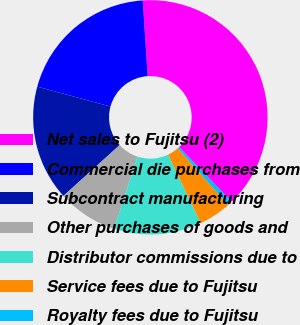Convert chart to OTSL. <chart><loc_0><loc_0><loc_500><loc_500><pie_chart><fcel>Net sales to Fujitsu (2)<fcel>Commercial die purchases from<fcel>Subcontract manufacturing<fcel>Other purchases of goods and<fcel>Distributor commissions due to<fcel>Service fees due to Fujitsu<fcel>Royalty fees due to Fujitsu<nl><fcel>38.83%<fcel>19.74%<fcel>15.92%<fcel>8.29%<fcel>12.1%<fcel>4.47%<fcel>0.65%<nl></chart> 